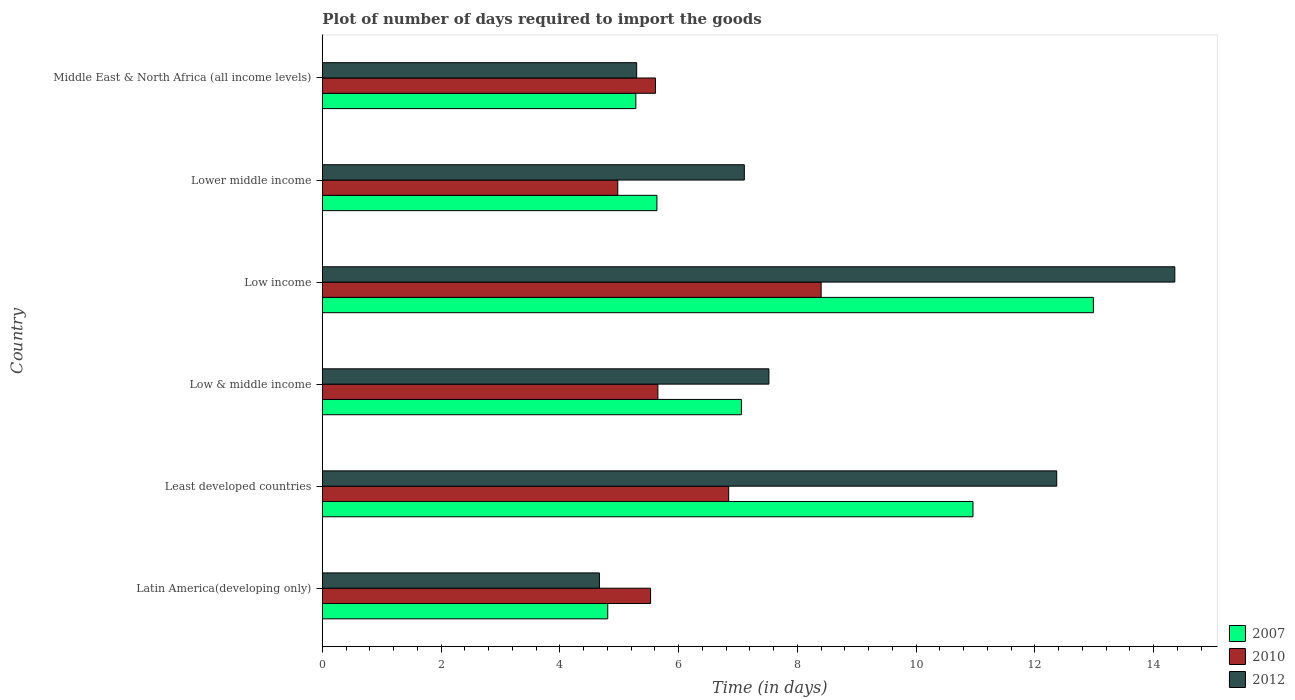How many different coloured bars are there?
Keep it short and to the point. 3. How many groups of bars are there?
Offer a terse response. 6. What is the label of the 6th group of bars from the top?
Ensure brevity in your answer.  Latin America(developing only). What is the time required to import goods in 2012 in Least developed countries?
Keep it short and to the point. 12.37. Across all countries, what is the maximum time required to import goods in 2007?
Ensure brevity in your answer.  12.99. Across all countries, what is the minimum time required to import goods in 2007?
Provide a succinct answer. 4.81. In which country was the time required to import goods in 2007 maximum?
Provide a short and direct response. Low income. In which country was the time required to import goods in 2010 minimum?
Provide a short and direct response. Lower middle income. What is the total time required to import goods in 2012 in the graph?
Your answer should be compact. 51.31. What is the difference between the time required to import goods in 2012 in Latin America(developing only) and that in Lower middle income?
Offer a terse response. -2.44. What is the difference between the time required to import goods in 2010 in Lower middle income and the time required to import goods in 2012 in Low income?
Ensure brevity in your answer.  -9.38. What is the average time required to import goods in 2010 per country?
Make the answer very short. 6.17. What is the difference between the time required to import goods in 2010 and time required to import goods in 2012 in Low & middle income?
Make the answer very short. -1.87. In how many countries, is the time required to import goods in 2012 greater than 14 days?
Keep it short and to the point. 1. What is the ratio of the time required to import goods in 2007 in Least developed countries to that in Middle East & North Africa (all income levels)?
Your response must be concise. 2.08. Is the time required to import goods in 2007 in Least developed countries less than that in Middle East & North Africa (all income levels)?
Offer a terse response. No. Is the difference between the time required to import goods in 2010 in Low & middle income and Middle East & North Africa (all income levels) greater than the difference between the time required to import goods in 2012 in Low & middle income and Middle East & North Africa (all income levels)?
Your answer should be compact. No. What is the difference between the highest and the second highest time required to import goods in 2012?
Your response must be concise. 1.99. What is the difference between the highest and the lowest time required to import goods in 2012?
Give a very brief answer. 9.69. Is it the case that in every country, the sum of the time required to import goods in 2012 and time required to import goods in 2010 is greater than the time required to import goods in 2007?
Ensure brevity in your answer.  Yes. Are all the bars in the graph horizontal?
Give a very brief answer. Yes. How many countries are there in the graph?
Keep it short and to the point. 6. Does the graph contain grids?
Offer a very short reply. No. How are the legend labels stacked?
Offer a terse response. Vertical. What is the title of the graph?
Offer a terse response. Plot of number of days required to import the goods. Does "2005" appear as one of the legend labels in the graph?
Give a very brief answer. No. What is the label or title of the X-axis?
Provide a succinct answer. Time (in days). What is the label or title of the Y-axis?
Your response must be concise. Country. What is the Time (in days) in 2007 in Latin America(developing only)?
Offer a very short reply. 4.81. What is the Time (in days) in 2010 in Latin America(developing only)?
Offer a terse response. 5.53. What is the Time (in days) of 2012 in Latin America(developing only)?
Make the answer very short. 4.67. What is the Time (in days) of 2007 in Least developed countries?
Provide a succinct answer. 10.96. What is the Time (in days) of 2010 in Least developed countries?
Provide a succinct answer. 6.84. What is the Time (in days) in 2012 in Least developed countries?
Provide a short and direct response. 12.37. What is the Time (in days) of 2007 in Low & middle income?
Offer a terse response. 7.06. What is the Time (in days) of 2010 in Low & middle income?
Offer a terse response. 5.65. What is the Time (in days) in 2012 in Low & middle income?
Give a very brief answer. 7.52. What is the Time (in days) of 2007 in Low income?
Make the answer very short. 12.99. What is the Time (in days) of 2010 in Low income?
Your answer should be compact. 8.4. What is the Time (in days) of 2012 in Low income?
Give a very brief answer. 14.36. What is the Time (in days) of 2007 in Lower middle income?
Your answer should be very brief. 5.63. What is the Time (in days) in 2010 in Lower middle income?
Provide a short and direct response. 4.98. What is the Time (in days) of 2012 in Lower middle income?
Provide a short and direct response. 7.11. What is the Time (in days) in 2007 in Middle East & North Africa (all income levels)?
Keep it short and to the point. 5.28. What is the Time (in days) of 2010 in Middle East & North Africa (all income levels)?
Provide a succinct answer. 5.61. What is the Time (in days) of 2012 in Middle East & North Africa (all income levels)?
Offer a terse response. 5.29. Across all countries, what is the maximum Time (in days) of 2007?
Make the answer very short. 12.99. Across all countries, what is the maximum Time (in days) in 2010?
Give a very brief answer. 8.4. Across all countries, what is the maximum Time (in days) in 2012?
Keep it short and to the point. 14.36. Across all countries, what is the minimum Time (in days) in 2007?
Your answer should be very brief. 4.81. Across all countries, what is the minimum Time (in days) of 2010?
Your answer should be very brief. 4.98. Across all countries, what is the minimum Time (in days) of 2012?
Your answer should be compact. 4.67. What is the total Time (in days) in 2007 in the graph?
Ensure brevity in your answer.  46.72. What is the total Time (in days) in 2010 in the graph?
Give a very brief answer. 37.01. What is the total Time (in days) in 2012 in the graph?
Your response must be concise. 51.31. What is the difference between the Time (in days) in 2007 in Latin America(developing only) and that in Least developed countries?
Your response must be concise. -6.15. What is the difference between the Time (in days) in 2010 in Latin America(developing only) and that in Least developed countries?
Ensure brevity in your answer.  -1.32. What is the difference between the Time (in days) in 2012 in Latin America(developing only) and that in Least developed countries?
Make the answer very short. -7.7. What is the difference between the Time (in days) in 2007 in Latin America(developing only) and that in Low & middle income?
Your response must be concise. -2.25. What is the difference between the Time (in days) in 2010 in Latin America(developing only) and that in Low & middle income?
Offer a terse response. -0.12. What is the difference between the Time (in days) of 2012 in Latin America(developing only) and that in Low & middle income?
Your response must be concise. -2.85. What is the difference between the Time (in days) of 2007 in Latin America(developing only) and that in Low income?
Your response must be concise. -8.18. What is the difference between the Time (in days) of 2010 in Latin America(developing only) and that in Low income?
Your answer should be very brief. -2.87. What is the difference between the Time (in days) in 2012 in Latin America(developing only) and that in Low income?
Provide a short and direct response. -9.69. What is the difference between the Time (in days) in 2007 in Latin America(developing only) and that in Lower middle income?
Make the answer very short. -0.83. What is the difference between the Time (in days) in 2010 in Latin America(developing only) and that in Lower middle income?
Provide a succinct answer. 0.55. What is the difference between the Time (in days) of 2012 in Latin America(developing only) and that in Lower middle income?
Provide a short and direct response. -2.44. What is the difference between the Time (in days) of 2007 in Latin America(developing only) and that in Middle East & North Africa (all income levels)?
Give a very brief answer. -0.47. What is the difference between the Time (in days) of 2010 in Latin America(developing only) and that in Middle East & North Africa (all income levels)?
Offer a terse response. -0.08. What is the difference between the Time (in days) of 2012 in Latin America(developing only) and that in Middle East & North Africa (all income levels)?
Give a very brief answer. -0.63. What is the difference between the Time (in days) in 2007 in Least developed countries and that in Low & middle income?
Make the answer very short. 3.9. What is the difference between the Time (in days) in 2010 in Least developed countries and that in Low & middle income?
Provide a short and direct response. 1.19. What is the difference between the Time (in days) of 2012 in Least developed countries and that in Low & middle income?
Your response must be concise. 4.85. What is the difference between the Time (in days) in 2007 in Least developed countries and that in Low income?
Provide a succinct answer. -2.03. What is the difference between the Time (in days) in 2010 in Least developed countries and that in Low income?
Ensure brevity in your answer.  -1.56. What is the difference between the Time (in days) of 2012 in Least developed countries and that in Low income?
Your response must be concise. -1.99. What is the difference between the Time (in days) in 2007 in Least developed countries and that in Lower middle income?
Provide a short and direct response. 5.32. What is the difference between the Time (in days) in 2010 in Least developed countries and that in Lower middle income?
Provide a succinct answer. 1.87. What is the difference between the Time (in days) of 2012 in Least developed countries and that in Lower middle income?
Provide a short and direct response. 5.26. What is the difference between the Time (in days) of 2007 in Least developed countries and that in Middle East & North Africa (all income levels)?
Your answer should be very brief. 5.68. What is the difference between the Time (in days) of 2010 in Least developed countries and that in Middle East & North Africa (all income levels)?
Offer a very short reply. 1.23. What is the difference between the Time (in days) of 2012 in Least developed countries and that in Middle East & North Africa (all income levels)?
Ensure brevity in your answer.  7.07. What is the difference between the Time (in days) in 2007 in Low & middle income and that in Low income?
Your response must be concise. -5.93. What is the difference between the Time (in days) in 2010 in Low & middle income and that in Low income?
Provide a short and direct response. -2.75. What is the difference between the Time (in days) of 2012 in Low & middle income and that in Low income?
Provide a succinct answer. -6.84. What is the difference between the Time (in days) in 2007 in Low & middle income and that in Lower middle income?
Offer a very short reply. 1.42. What is the difference between the Time (in days) in 2010 in Low & middle income and that in Lower middle income?
Provide a short and direct response. 0.68. What is the difference between the Time (in days) of 2012 in Low & middle income and that in Lower middle income?
Keep it short and to the point. 0.41. What is the difference between the Time (in days) of 2007 in Low & middle income and that in Middle East & North Africa (all income levels)?
Give a very brief answer. 1.78. What is the difference between the Time (in days) in 2010 in Low & middle income and that in Middle East & North Africa (all income levels)?
Provide a succinct answer. 0.04. What is the difference between the Time (in days) of 2012 in Low & middle income and that in Middle East & North Africa (all income levels)?
Your answer should be very brief. 2.23. What is the difference between the Time (in days) in 2007 in Low income and that in Lower middle income?
Offer a terse response. 7.35. What is the difference between the Time (in days) in 2010 in Low income and that in Lower middle income?
Offer a terse response. 3.42. What is the difference between the Time (in days) of 2012 in Low income and that in Lower middle income?
Give a very brief answer. 7.25. What is the difference between the Time (in days) in 2007 in Low income and that in Middle East & North Africa (all income levels)?
Your response must be concise. 7.71. What is the difference between the Time (in days) of 2010 in Low income and that in Middle East & North Africa (all income levels)?
Give a very brief answer. 2.79. What is the difference between the Time (in days) in 2012 in Low income and that in Middle East & North Africa (all income levels)?
Keep it short and to the point. 9.06. What is the difference between the Time (in days) of 2007 in Lower middle income and that in Middle East & North Africa (all income levels)?
Make the answer very short. 0.35. What is the difference between the Time (in days) of 2010 in Lower middle income and that in Middle East & North Africa (all income levels)?
Your answer should be compact. -0.64. What is the difference between the Time (in days) in 2012 in Lower middle income and that in Middle East & North Africa (all income levels)?
Make the answer very short. 1.81. What is the difference between the Time (in days) of 2007 in Latin America(developing only) and the Time (in days) of 2010 in Least developed countries?
Your answer should be compact. -2.04. What is the difference between the Time (in days) in 2007 in Latin America(developing only) and the Time (in days) in 2012 in Least developed countries?
Ensure brevity in your answer.  -7.56. What is the difference between the Time (in days) in 2010 in Latin America(developing only) and the Time (in days) in 2012 in Least developed countries?
Give a very brief answer. -6.84. What is the difference between the Time (in days) of 2007 in Latin America(developing only) and the Time (in days) of 2010 in Low & middle income?
Provide a succinct answer. -0.84. What is the difference between the Time (in days) of 2007 in Latin America(developing only) and the Time (in days) of 2012 in Low & middle income?
Your answer should be very brief. -2.71. What is the difference between the Time (in days) in 2010 in Latin America(developing only) and the Time (in days) in 2012 in Low & middle income?
Offer a very short reply. -1.99. What is the difference between the Time (in days) of 2007 in Latin America(developing only) and the Time (in days) of 2010 in Low income?
Your answer should be very brief. -3.59. What is the difference between the Time (in days) in 2007 in Latin America(developing only) and the Time (in days) in 2012 in Low income?
Keep it short and to the point. -9.55. What is the difference between the Time (in days) in 2010 in Latin America(developing only) and the Time (in days) in 2012 in Low income?
Your answer should be compact. -8.83. What is the difference between the Time (in days) of 2007 in Latin America(developing only) and the Time (in days) of 2010 in Lower middle income?
Provide a succinct answer. -0.17. What is the difference between the Time (in days) in 2007 in Latin America(developing only) and the Time (in days) in 2012 in Lower middle income?
Offer a terse response. -2.3. What is the difference between the Time (in days) of 2010 in Latin America(developing only) and the Time (in days) of 2012 in Lower middle income?
Offer a very short reply. -1.58. What is the difference between the Time (in days) in 2007 in Latin America(developing only) and the Time (in days) in 2010 in Middle East & North Africa (all income levels)?
Give a very brief answer. -0.8. What is the difference between the Time (in days) of 2007 in Latin America(developing only) and the Time (in days) of 2012 in Middle East & North Africa (all income levels)?
Offer a very short reply. -0.49. What is the difference between the Time (in days) in 2010 in Latin America(developing only) and the Time (in days) in 2012 in Middle East & North Africa (all income levels)?
Provide a short and direct response. 0.23. What is the difference between the Time (in days) in 2007 in Least developed countries and the Time (in days) in 2010 in Low & middle income?
Offer a very short reply. 5.31. What is the difference between the Time (in days) in 2007 in Least developed countries and the Time (in days) in 2012 in Low & middle income?
Your response must be concise. 3.44. What is the difference between the Time (in days) of 2010 in Least developed countries and the Time (in days) of 2012 in Low & middle income?
Keep it short and to the point. -0.68. What is the difference between the Time (in days) in 2007 in Least developed countries and the Time (in days) in 2010 in Low income?
Your answer should be very brief. 2.56. What is the difference between the Time (in days) of 2007 in Least developed countries and the Time (in days) of 2012 in Low income?
Keep it short and to the point. -3.4. What is the difference between the Time (in days) of 2010 in Least developed countries and the Time (in days) of 2012 in Low income?
Your answer should be very brief. -7.51. What is the difference between the Time (in days) of 2007 in Least developed countries and the Time (in days) of 2010 in Lower middle income?
Keep it short and to the point. 5.98. What is the difference between the Time (in days) in 2007 in Least developed countries and the Time (in days) in 2012 in Lower middle income?
Your response must be concise. 3.85. What is the difference between the Time (in days) of 2010 in Least developed countries and the Time (in days) of 2012 in Lower middle income?
Ensure brevity in your answer.  -0.26. What is the difference between the Time (in days) in 2007 in Least developed countries and the Time (in days) in 2010 in Middle East & North Africa (all income levels)?
Your answer should be very brief. 5.35. What is the difference between the Time (in days) of 2007 in Least developed countries and the Time (in days) of 2012 in Middle East & North Africa (all income levels)?
Your answer should be compact. 5.66. What is the difference between the Time (in days) in 2010 in Least developed countries and the Time (in days) in 2012 in Middle East & North Africa (all income levels)?
Provide a succinct answer. 1.55. What is the difference between the Time (in days) in 2007 in Low & middle income and the Time (in days) in 2010 in Low income?
Give a very brief answer. -1.34. What is the difference between the Time (in days) of 2007 in Low & middle income and the Time (in days) of 2012 in Low income?
Keep it short and to the point. -7.3. What is the difference between the Time (in days) in 2010 in Low & middle income and the Time (in days) in 2012 in Low income?
Your response must be concise. -8.71. What is the difference between the Time (in days) in 2007 in Low & middle income and the Time (in days) in 2010 in Lower middle income?
Give a very brief answer. 2.08. What is the difference between the Time (in days) of 2007 in Low & middle income and the Time (in days) of 2012 in Lower middle income?
Ensure brevity in your answer.  -0.05. What is the difference between the Time (in days) of 2010 in Low & middle income and the Time (in days) of 2012 in Lower middle income?
Make the answer very short. -1.46. What is the difference between the Time (in days) in 2007 in Low & middle income and the Time (in days) in 2010 in Middle East & North Africa (all income levels)?
Your answer should be compact. 1.45. What is the difference between the Time (in days) of 2007 in Low & middle income and the Time (in days) of 2012 in Middle East & North Africa (all income levels)?
Make the answer very short. 1.76. What is the difference between the Time (in days) in 2010 in Low & middle income and the Time (in days) in 2012 in Middle East & North Africa (all income levels)?
Keep it short and to the point. 0.36. What is the difference between the Time (in days) of 2007 in Low income and the Time (in days) of 2010 in Lower middle income?
Your answer should be very brief. 8.01. What is the difference between the Time (in days) of 2007 in Low income and the Time (in days) of 2012 in Lower middle income?
Provide a short and direct response. 5.88. What is the difference between the Time (in days) in 2010 in Low income and the Time (in days) in 2012 in Lower middle income?
Your answer should be very brief. 1.29. What is the difference between the Time (in days) in 2007 in Low income and the Time (in days) in 2010 in Middle East & North Africa (all income levels)?
Make the answer very short. 7.37. What is the difference between the Time (in days) of 2007 in Low income and the Time (in days) of 2012 in Middle East & North Africa (all income levels)?
Make the answer very short. 7.69. What is the difference between the Time (in days) of 2010 in Low income and the Time (in days) of 2012 in Middle East & North Africa (all income levels)?
Give a very brief answer. 3.11. What is the difference between the Time (in days) of 2007 in Lower middle income and the Time (in days) of 2010 in Middle East & North Africa (all income levels)?
Your response must be concise. 0.02. What is the difference between the Time (in days) of 2007 in Lower middle income and the Time (in days) of 2012 in Middle East & North Africa (all income levels)?
Ensure brevity in your answer.  0.34. What is the difference between the Time (in days) of 2010 in Lower middle income and the Time (in days) of 2012 in Middle East & North Africa (all income levels)?
Give a very brief answer. -0.32. What is the average Time (in days) in 2007 per country?
Provide a short and direct response. 7.79. What is the average Time (in days) in 2010 per country?
Provide a short and direct response. 6.17. What is the average Time (in days) in 2012 per country?
Give a very brief answer. 8.55. What is the difference between the Time (in days) in 2007 and Time (in days) in 2010 in Latin America(developing only)?
Your answer should be compact. -0.72. What is the difference between the Time (in days) in 2007 and Time (in days) in 2012 in Latin America(developing only)?
Provide a succinct answer. 0.14. What is the difference between the Time (in days) in 2010 and Time (in days) in 2012 in Latin America(developing only)?
Provide a short and direct response. 0.86. What is the difference between the Time (in days) in 2007 and Time (in days) in 2010 in Least developed countries?
Ensure brevity in your answer.  4.11. What is the difference between the Time (in days) in 2007 and Time (in days) in 2012 in Least developed countries?
Keep it short and to the point. -1.41. What is the difference between the Time (in days) in 2010 and Time (in days) in 2012 in Least developed countries?
Make the answer very short. -5.52. What is the difference between the Time (in days) in 2007 and Time (in days) in 2010 in Low & middle income?
Your answer should be very brief. 1.41. What is the difference between the Time (in days) of 2007 and Time (in days) of 2012 in Low & middle income?
Offer a terse response. -0.46. What is the difference between the Time (in days) in 2010 and Time (in days) in 2012 in Low & middle income?
Give a very brief answer. -1.87. What is the difference between the Time (in days) in 2007 and Time (in days) in 2010 in Low income?
Your answer should be very brief. 4.58. What is the difference between the Time (in days) in 2007 and Time (in days) in 2012 in Low income?
Give a very brief answer. -1.37. What is the difference between the Time (in days) of 2010 and Time (in days) of 2012 in Low income?
Make the answer very short. -5.96. What is the difference between the Time (in days) of 2007 and Time (in days) of 2010 in Lower middle income?
Ensure brevity in your answer.  0.66. What is the difference between the Time (in days) of 2007 and Time (in days) of 2012 in Lower middle income?
Offer a very short reply. -1.47. What is the difference between the Time (in days) of 2010 and Time (in days) of 2012 in Lower middle income?
Keep it short and to the point. -2.13. What is the difference between the Time (in days) of 2007 and Time (in days) of 2010 in Middle East & North Africa (all income levels)?
Your answer should be compact. -0.33. What is the difference between the Time (in days) in 2007 and Time (in days) in 2012 in Middle East & North Africa (all income levels)?
Keep it short and to the point. -0.01. What is the difference between the Time (in days) of 2010 and Time (in days) of 2012 in Middle East & North Africa (all income levels)?
Your answer should be very brief. 0.32. What is the ratio of the Time (in days) of 2007 in Latin America(developing only) to that in Least developed countries?
Offer a very short reply. 0.44. What is the ratio of the Time (in days) in 2010 in Latin America(developing only) to that in Least developed countries?
Your answer should be compact. 0.81. What is the ratio of the Time (in days) in 2012 in Latin America(developing only) to that in Least developed countries?
Your answer should be very brief. 0.38. What is the ratio of the Time (in days) of 2007 in Latin America(developing only) to that in Low & middle income?
Ensure brevity in your answer.  0.68. What is the ratio of the Time (in days) of 2010 in Latin America(developing only) to that in Low & middle income?
Make the answer very short. 0.98. What is the ratio of the Time (in days) in 2012 in Latin America(developing only) to that in Low & middle income?
Ensure brevity in your answer.  0.62. What is the ratio of the Time (in days) in 2007 in Latin America(developing only) to that in Low income?
Provide a succinct answer. 0.37. What is the ratio of the Time (in days) in 2010 in Latin America(developing only) to that in Low income?
Provide a short and direct response. 0.66. What is the ratio of the Time (in days) in 2012 in Latin America(developing only) to that in Low income?
Your answer should be compact. 0.33. What is the ratio of the Time (in days) in 2007 in Latin America(developing only) to that in Lower middle income?
Offer a very short reply. 0.85. What is the ratio of the Time (in days) of 2010 in Latin America(developing only) to that in Lower middle income?
Offer a terse response. 1.11. What is the ratio of the Time (in days) in 2012 in Latin America(developing only) to that in Lower middle income?
Ensure brevity in your answer.  0.66. What is the ratio of the Time (in days) of 2007 in Latin America(developing only) to that in Middle East & North Africa (all income levels)?
Provide a short and direct response. 0.91. What is the ratio of the Time (in days) in 2010 in Latin America(developing only) to that in Middle East & North Africa (all income levels)?
Make the answer very short. 0.99. What is the ratio of the Time (in days) of 2012 in Latin America(developing only) to that in Middle East & North Africa (all income levels)?
Provide a succinct answer. 0.88. What is the ratio of the Time (in days) in 2007 in Least developed countries to that in Low & middle income?
Your response must be concise. 1.55. What is the ratio of the Time (in days) of 2010 in Least developed countries to that in Low & middle income?
Ensure brevity in your answer.  1.21. What is the ratio of the Time (in days) of 2012 in Least developed countries to that in Low & middle income?
Your response must be concise. 1.64. What is the ratio of the Time (in days) of 2007 in Least developed countries to that in Low income?
Offer a very short reply. 0.84. What is the ratio of the Time (in days) in 2010 in Least developed countries to that in Low income?
Provide a succinct answer. 0.81. What is the ratio of the Time (in days) of 2012 in Least developed countries to that in Low income?
Offer a very short reply. 0.86. What is the ratio of the Time (in days) of 2007 in Least developed countries to that in Lower middle income?
Your answer should be compact. 1.94. What is the ratio of the Time (in days) in 2010 in Least developed countries to that in Lower middle income?
Give a very brief answer. 1.38. What is the ratio of the Time (in days) in 2012 in Least developed countries to that in Lower middle income?
Provide a short and direct response. 1.74. What is the ratio of the Time (in days) of 2007 in Least developed countries to that in Middle East & North Africa (all income levels)?
Your answer should be very brief. 2.08. What is the ratio of the Time (in days) of 2010 in Least developed countries to that in Middle East & North Africa (all income levels)?
Offer a very short reply. 1.22. What is the ratio of the Time (in days) in 2012 in Least developed countries to that in Middle East & North Africa (all income levels)?
Your response must be concise. 2.34. What is the ratio of the Time (in days) in 2007 in Low & middle income to that in Low income?
Offer a very short reply. 0.54. What is the ratio of the Time (in days) in 2010 in Low & middle income to that in Low income?
Your answer should be compact. 0.67. What is the ratio of the Time (in days) in 2012 in Low & middle income to that in Low income?
Give a very brief answer. 0.52. What is the ratio of the Time (in days) in 2007 in Low & middle income to that in Lower middle income?
Your answer should be very brief. 1.25. What is the ratio of the Time (in days) of 2010 in Low & middle income to that in Lower middle income?
Your answer should be compact. 1.14. What is the ratio of the Time (in days) of 2012 in Low & middle income to that in Lower middle income?
Make the answer very short. 1.06. What is the ratio of the Time (in days) in 2007 in Low & middle income to that in Middle East & North Africa (all income levels)?
Provide a succinct answer. 1.34. What is the ratio of the Time (in days) of 2010 in Low & middle income to that in Middle East & North Africa (all income levels)?
Make the answer very short. 1.01. What is the ratio of the Time (in days) of 2012 in Low & middle income to that in Middle East & North Africa (all income levels)?
Offer a terse response. 1.42. What is the ratio of the Time (in days) in 2007 in Low income to that in Lower middle income?
Your answer should be very brief. 2.3. What is the ratio of the Time (in days) of 2010 in Low income to that in Lower middle income?
Your response must be concise. 1.69. What is the ratio of the Time (in days) in 2012 in Low income to that in Lower middle income?
Provide a succinct answer. 2.02. What is the ratio of the Time (in days) of 2007 in Low income to that in Middle East & North Africa (all income levels)?
Your answer should be very brief. 2.46. What is the ratio of the Time (in days) of 2010 in Low income to that in Middle East & North Africa (all income levels)?
Make the answer very short. 1.5. What is the ratio of the Time (in days) of 2012 in Low income to that in Middle East & North Africa (all income levels)?
Give a very brief answer. 2.71. What is the ratio of the Time (in days) of 2007 in Lower middle income to that in Middle East & North Africa (all income levels)?
Provide a short and direct response. 1.07. What is the ratio of the Time (in days) in 2010 in Lower middle income to that in Middle East & North Africa (all income levels)?
Ensure brevity in your answer.  0.89. What is the ratio of the Time (in days) in 2012 in Lower middle income to that in Middle East & North Africa (all income levels)?
Your answer should be very brief. 1.34. What is the difference between the highest and the second highest Time (in days) of 2007?
Offer a very short reply. 2.03. What is the difference between the highest and the second highest Time (in days) in 2010?
Offer a very short reply. 1.56. What is the difference between the highest and the second highest Time (in days) of 2012?
Ensure brevity in your answer.  1.99. What is the difference between the highest and the lowest Time (in days) in 2007?
Provide a short and direct response. 8.18. What is the difference between the highest and the lowest Time (in days) of 2010?
Provide a succinct answer. 3.42. What is the difference between the highest and the lowest Time (in days) of 2012?
Your answer should be compact. 9.69. 